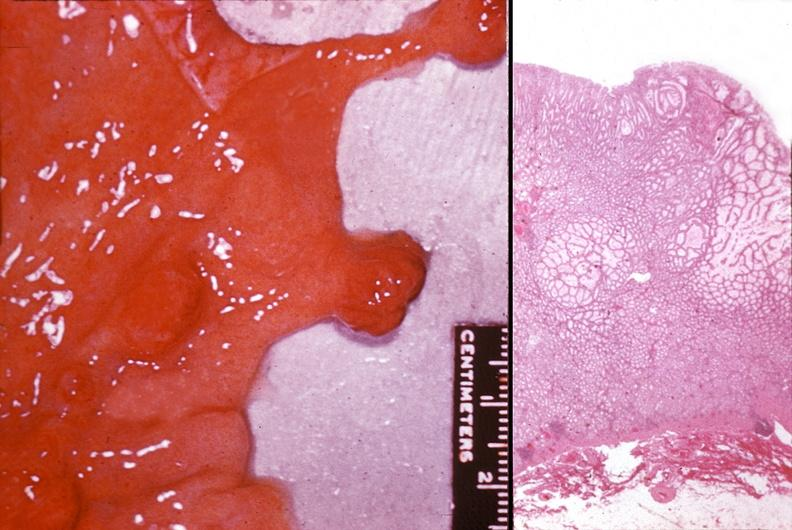what is present?
Answer the question using a single word or phrase. Gastrointestinal 